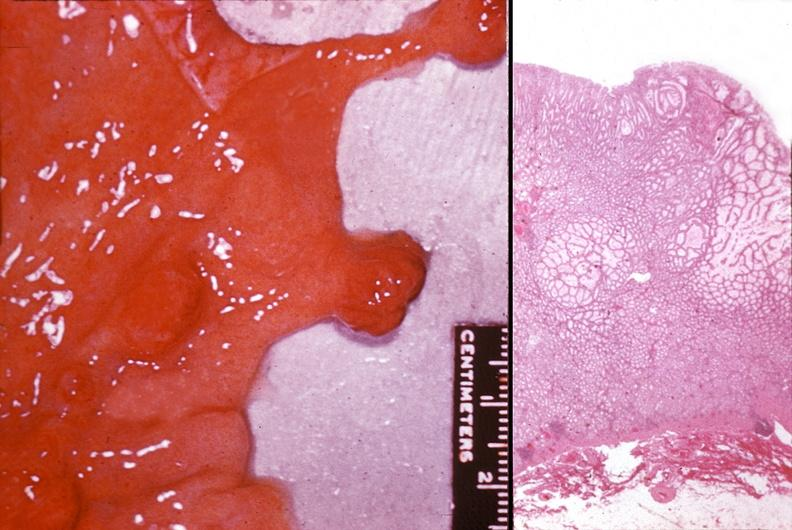what is present?
Answer the question using a single word or phrase. Gastrointestinal 